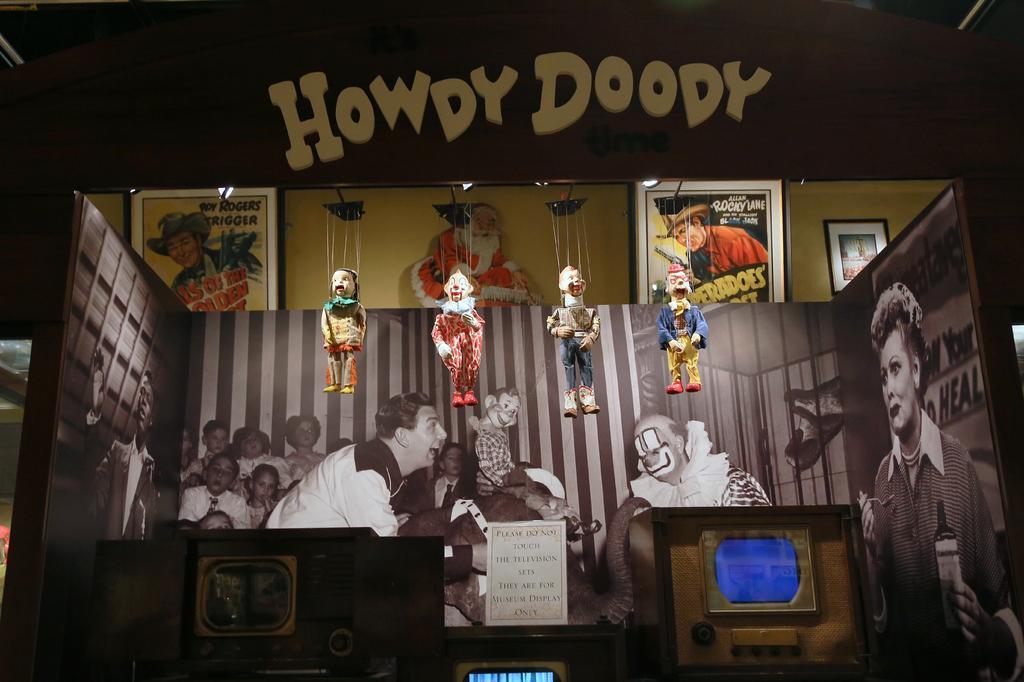How would you summarize this image in a sentence or two? In the foreground of this picture we can see there are some objects and we can see the pictures of group of persons and pictures of some other objects. In the center we can see the toys hanging on the board on which we can see the text. In the background we can see the picture frames on which we can see the pictures of persons and the text and we can see the picture of a Santa Claus. 